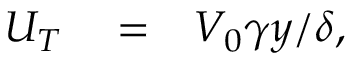<formula> <loc_0><loc_0><loc_500><loc_500>\begin{array} { r l r } { U _ { T } } & = } & { V _ { 0 } \gamma y / \delta , } \end{array}</formula> 